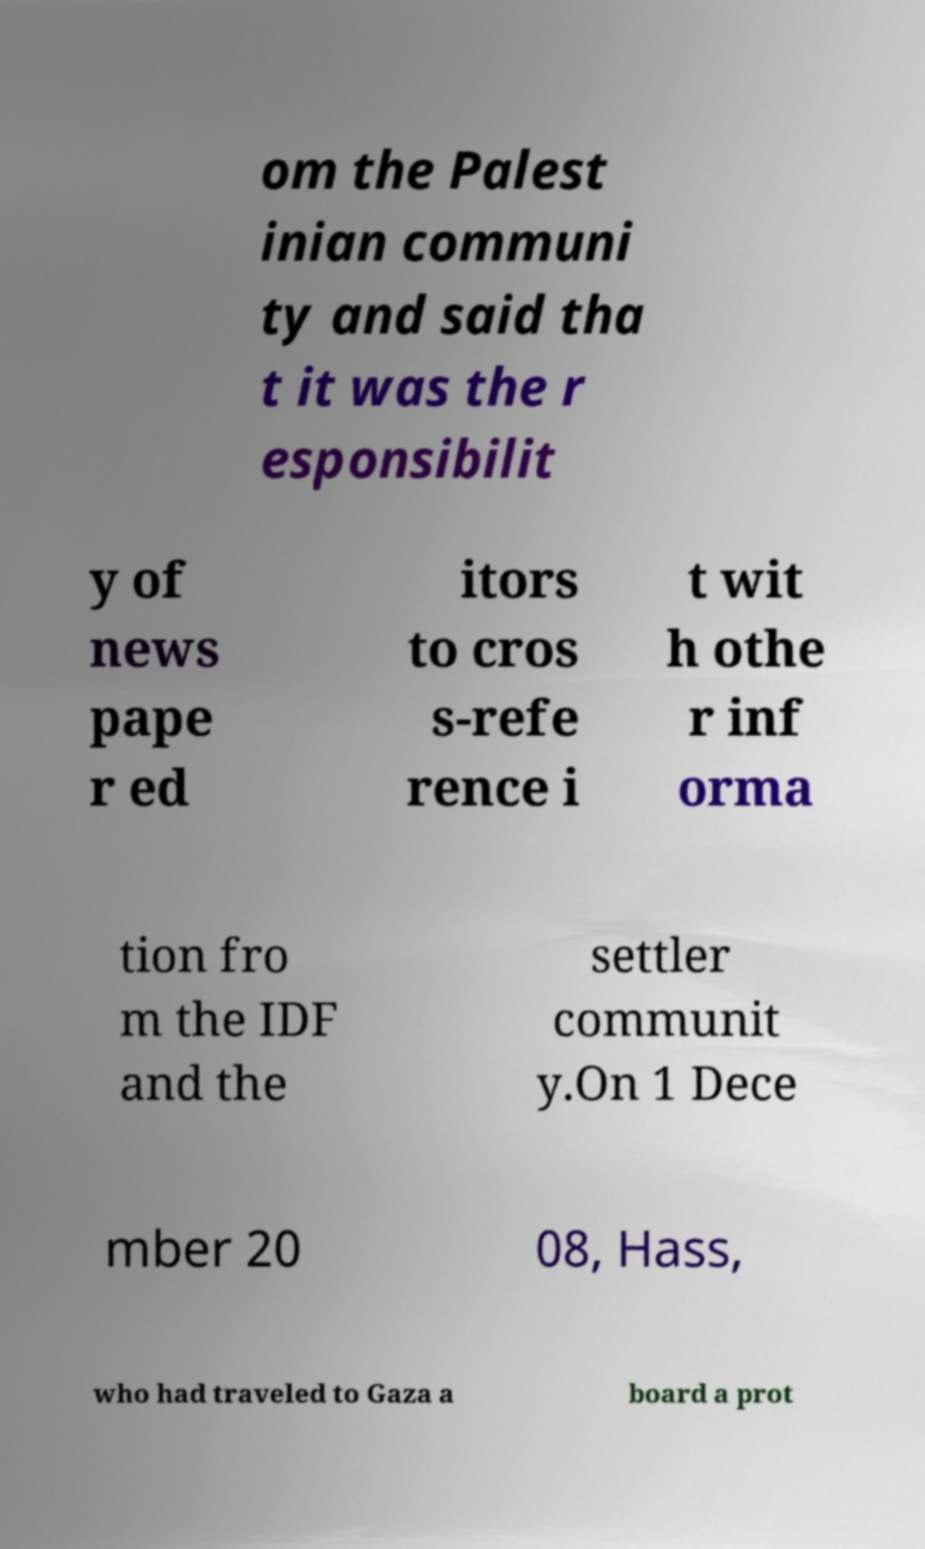Please identify and transcribe the text found in this image. om the Palest inian communi ty and said tha t it was the r esponsibilit y of news pape r ed itors to cros s-refe rence i t wit h othe r inf orma tion fro m the IDF and the settler communit y.On 1 Dece mber 20 08, Hass, who had traveled to Gaza a board a prot 